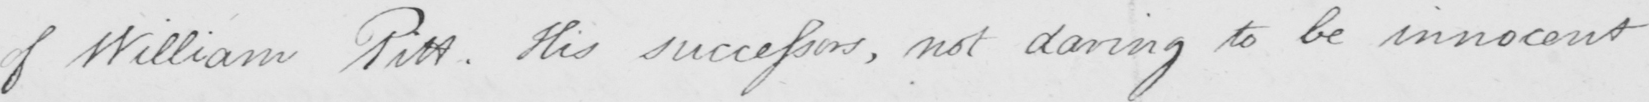Can you read and transcribe this handwriting? of William Pitt . His successors , not daring to be innocent 